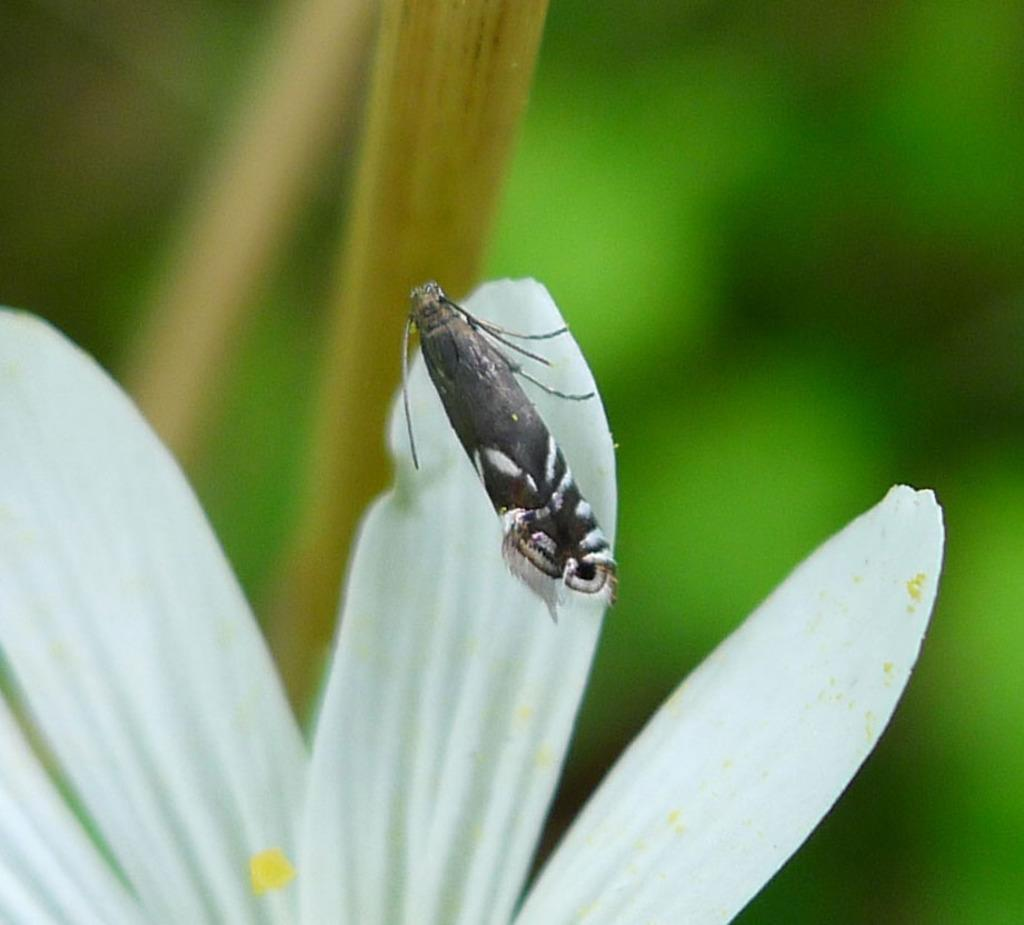What is the main subject of the image? There is an insect in the image. Where is the insect located? The insect is on a flower. Can you describe the background of the image? The background of the image is blurred. What type of weather can be seen in the image? There is no indication of weather in the image, as it focuses on the insect and the flower. How many frogs are present in the image? There are no frogs present in the image; it features an insect on a flower. 